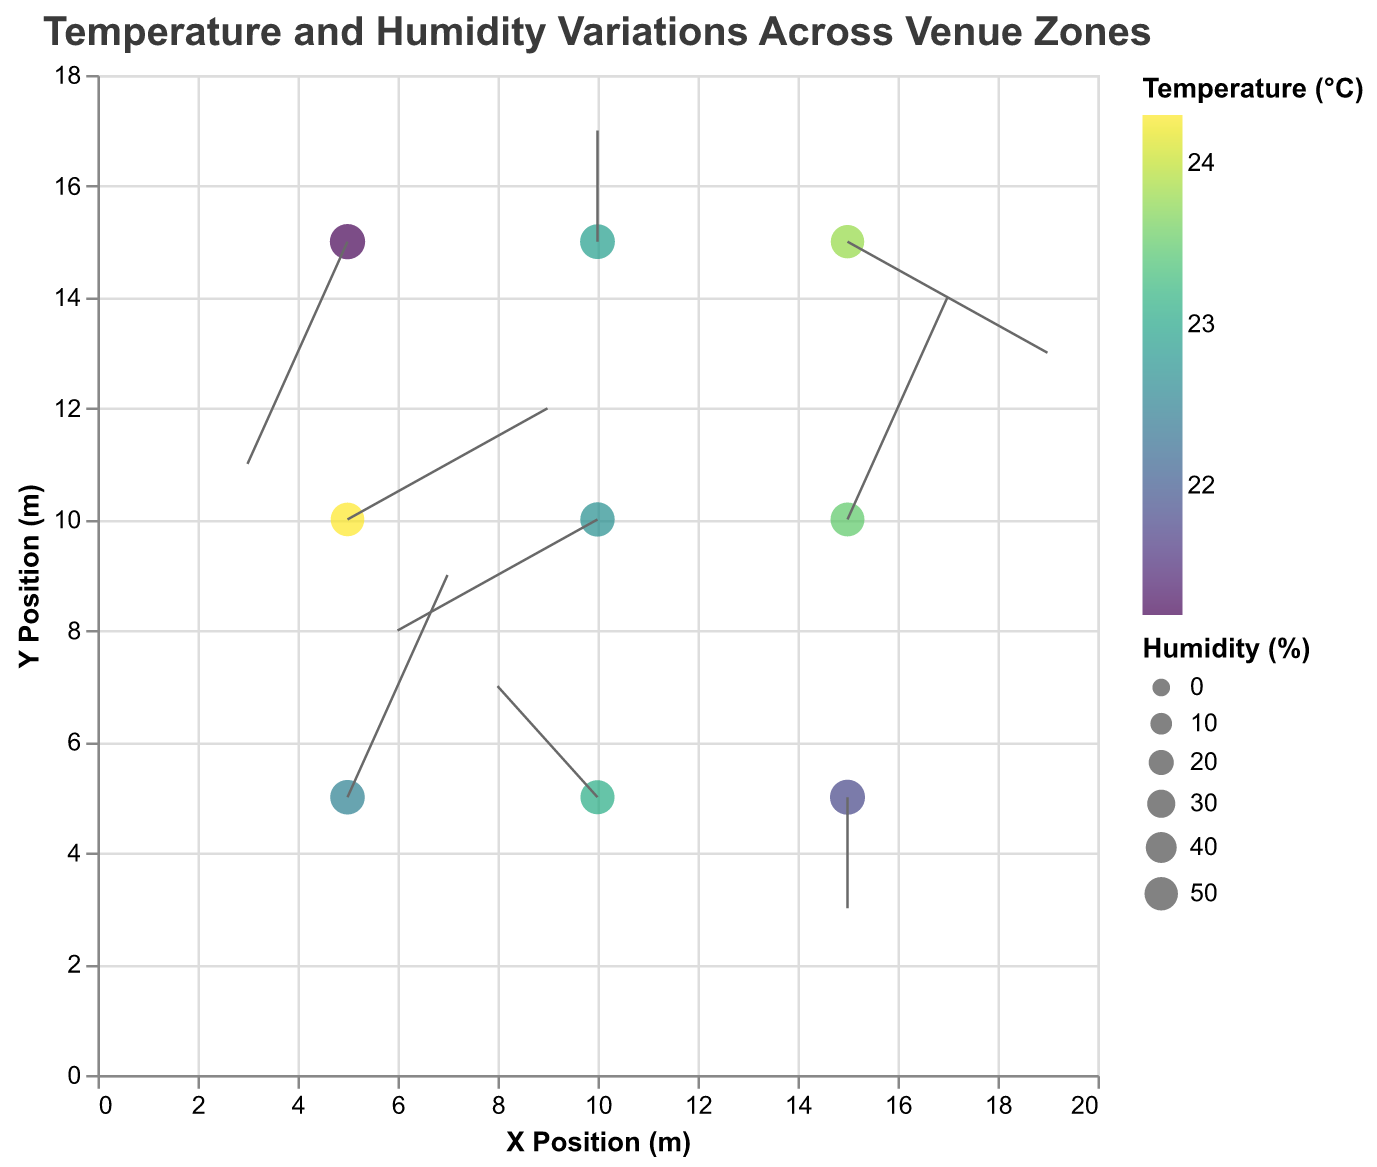How is the temperature distributed across different zones in the venue? By observing the color of the points, we can see variations in temperature, with colors ranging from yellow to green to blue.
Answer: It varies from yellow (warmer) to blue (cooler) What is the general trend of humidity in the central zone (10,10)? The size of the point at coordinates (10,10) represents the humidity, which is relatively moderate compared to other points.
Answer: Moderate Which zone has the highest temperature? The color representing temperature is brightest (yellow) at coordinates (5,10), indicating the highest temperature.
Answer: (5,10) In which direction does the air move in the top-left zone (5,15)? The quiver (arrow) at coordinates (5,15) points left and downward, suggesting air movement in those directions.
Answer: Left and downward Compare the humidity levels in zones (5,5) and (10,5). Which one is higher? The sizes of the points indicate humidity levels, and the point at (5,5) is larger than the one at (10,5), suggesting higher humidity at (5,5).
Answer: (5,5) What is the temperature at the point where x = 15 and y = 10? The color of the point at coordinates (15,10) matches the temperature scale legend, which corresponds to about 23.5°C.
Answer: 23.5°C Describe the air movement in the bottom-right zone (15,15). The arrow at coordinates (15,15) points to the right and slightly downward, indicating air moving to the right and downward.
Answer: Right and downward Which two zones have opposite air movement directions? The zones at (5,5) and (10,10) have arrows pointing upwards, while the zones at (5,15) and (10,15) have arrows pointing downwards.
Answer: (5,5) and (5,15) Is there any correlation between humidity and temperature in this plot? Higher humidity generally corresponds to cooler temperatures (larger blue points) and vice versa (smaller yellow points).
Answer: Yes Analyze the air movement pattern from left to right in the middle row (y=10). Arrows generally show a leftward movement on the left (negative x direction), while they point towards the rightward movement on the right side (positive x direction).
Answer: Leftward on the left, rightward on the right 